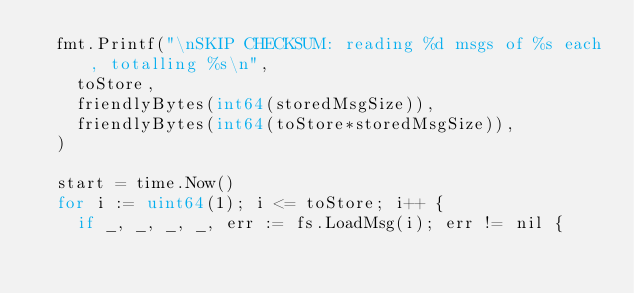Convert code to text. <code><loc_0><loc_0><loc_500><loc_500><_Go_>	fmt.Printf("\nSKIP CHECKSUM: reading %d msgs of %s each, totalling %s\n",
		toStore,
		friendlyBytes(int64(storedMsgSize)),
		friendlyBytes(int64(toStore*storedMsgSize)),
	)

	start = time.Now()
	for i := uint64(1); i <= toStore; i++ {
		if _, _, _, _, err := fs.LoadMsg(i); err != nil {</code> 